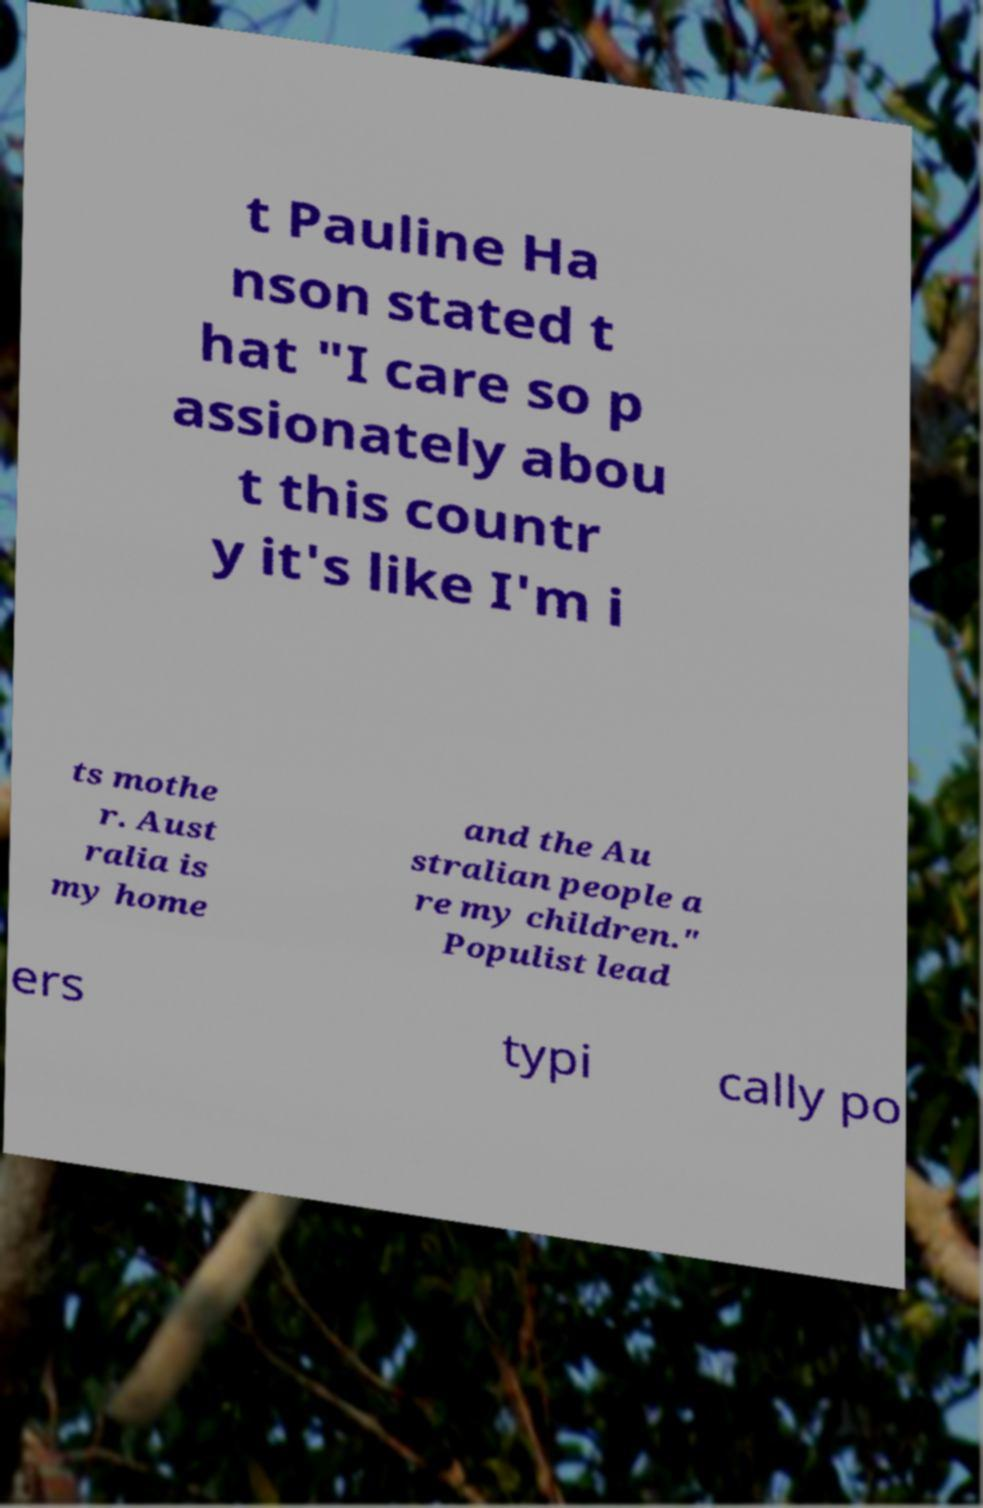For documentation purposes, I need the text within this image transcribed. Could you provide that? t Pauline Ha nson stated t hat "I care so p assionately abou t this countr y it's like I'm i ts mothe r. Aust ralia is my home and the Au stralian people a re my children." Populist lead ers typi cally po 